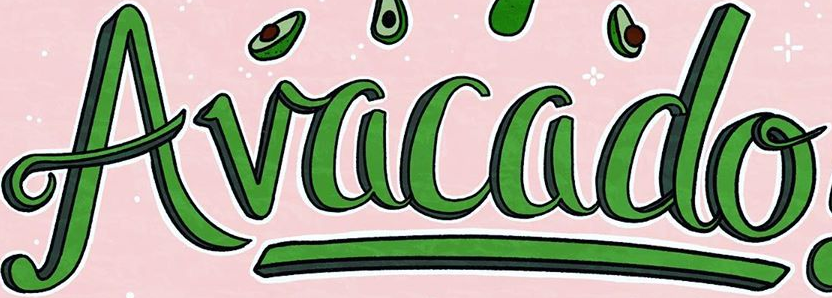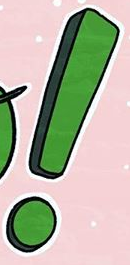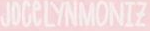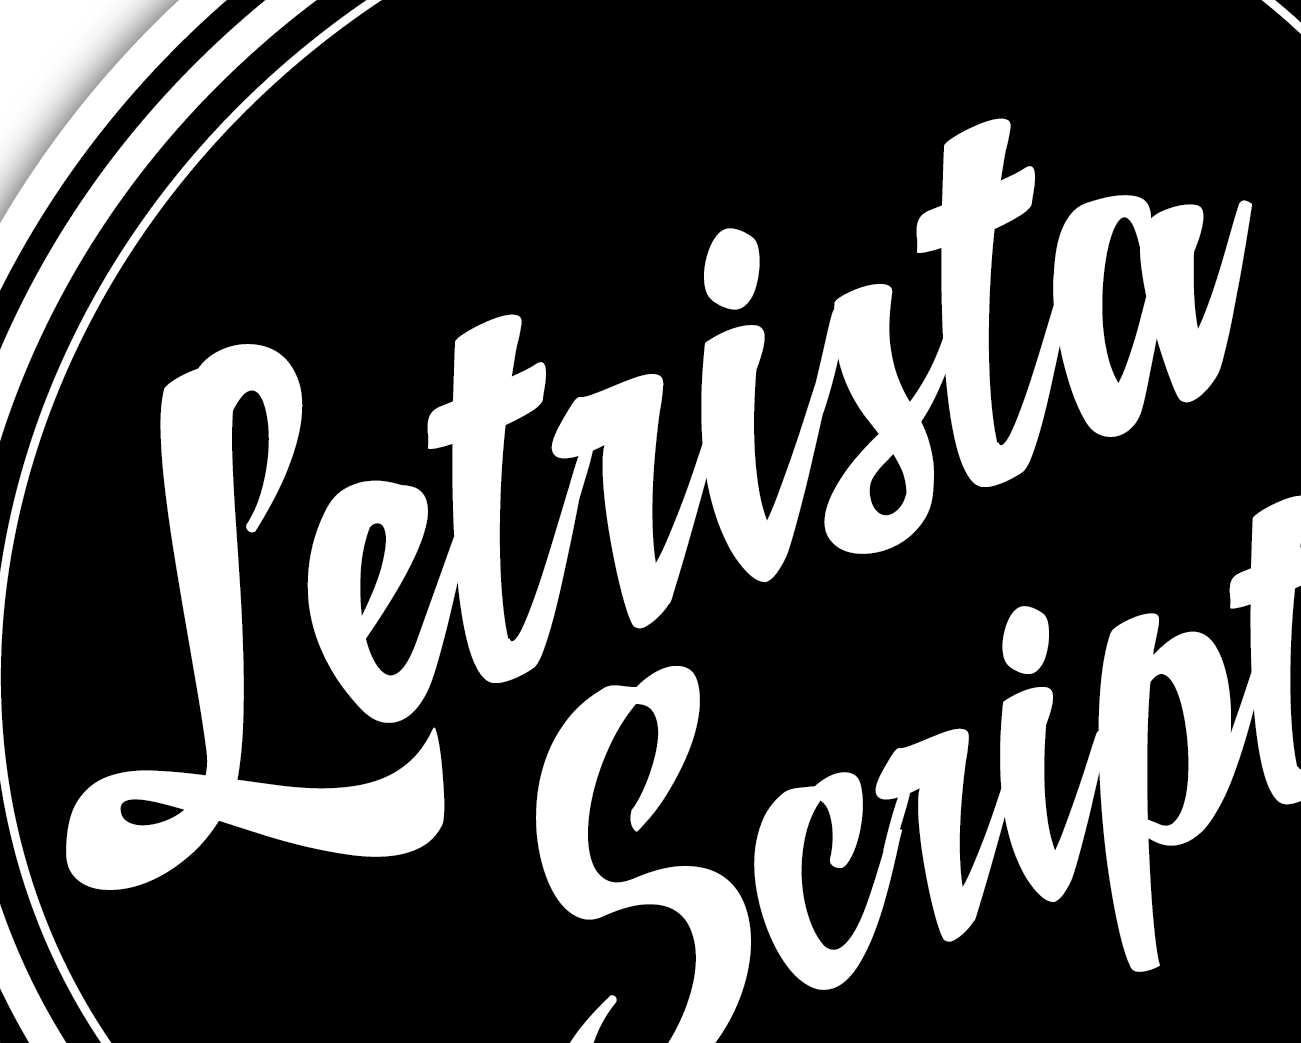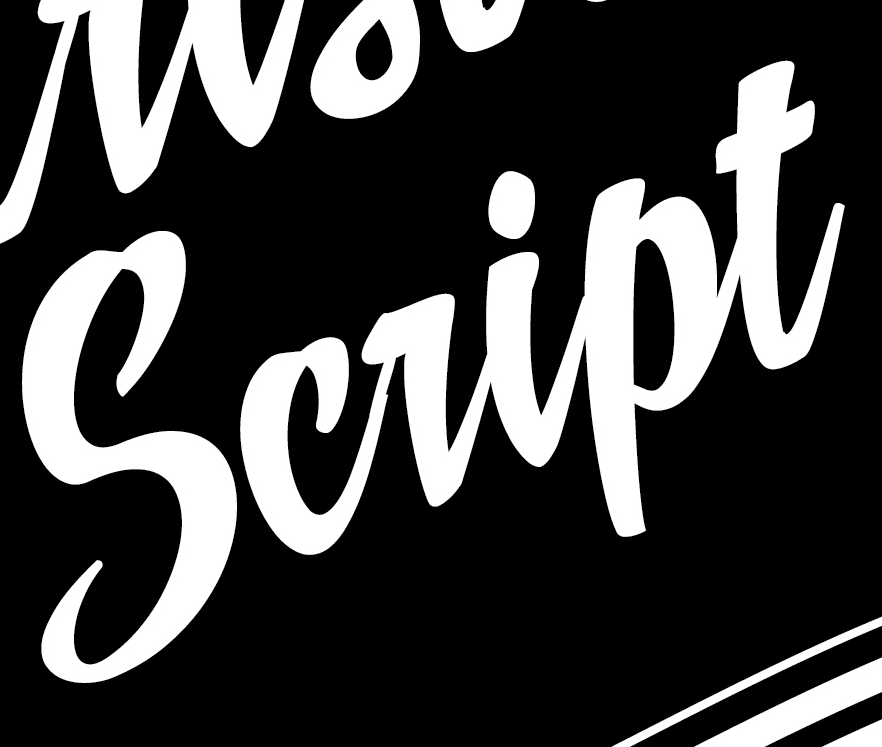What words can you see in these images in sequence, separated by a semicolon? Avacado; !; JOCeLYNMONIZ; Letrista; script 